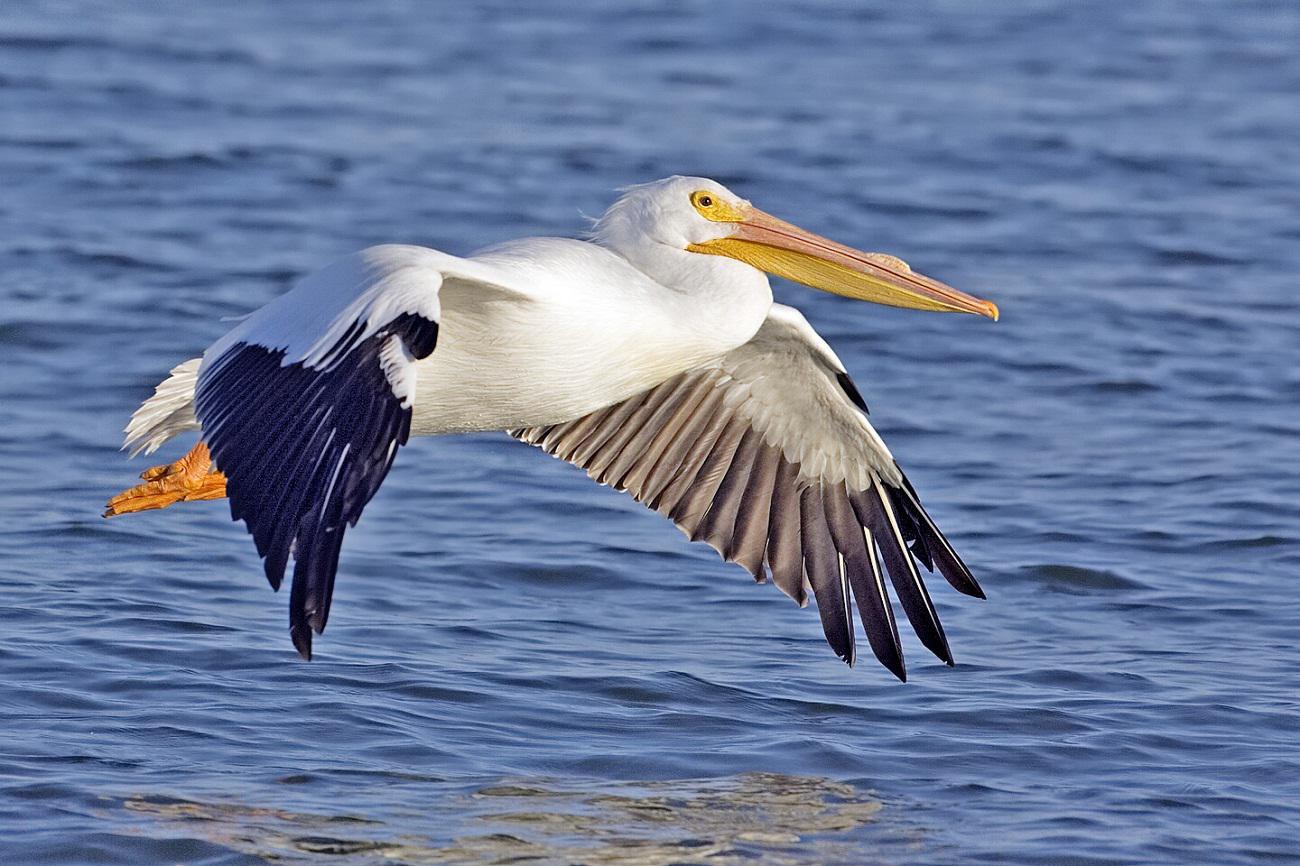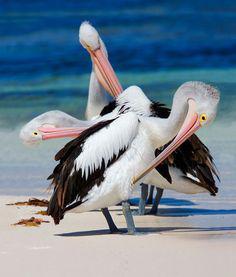The first image is the image on the left, the second image is the image on the right. Assess this claim about the two images: "An image shows one white-bodied pelican above blue water, with outstretched wings.". Correct or not? Answer yes or no. Yes. The first image is the image on the left, the second image is the image on the right. For the images displayed, is the sentence "At least one bird is sitting in water." factually correct? Answer yes or no. No. 